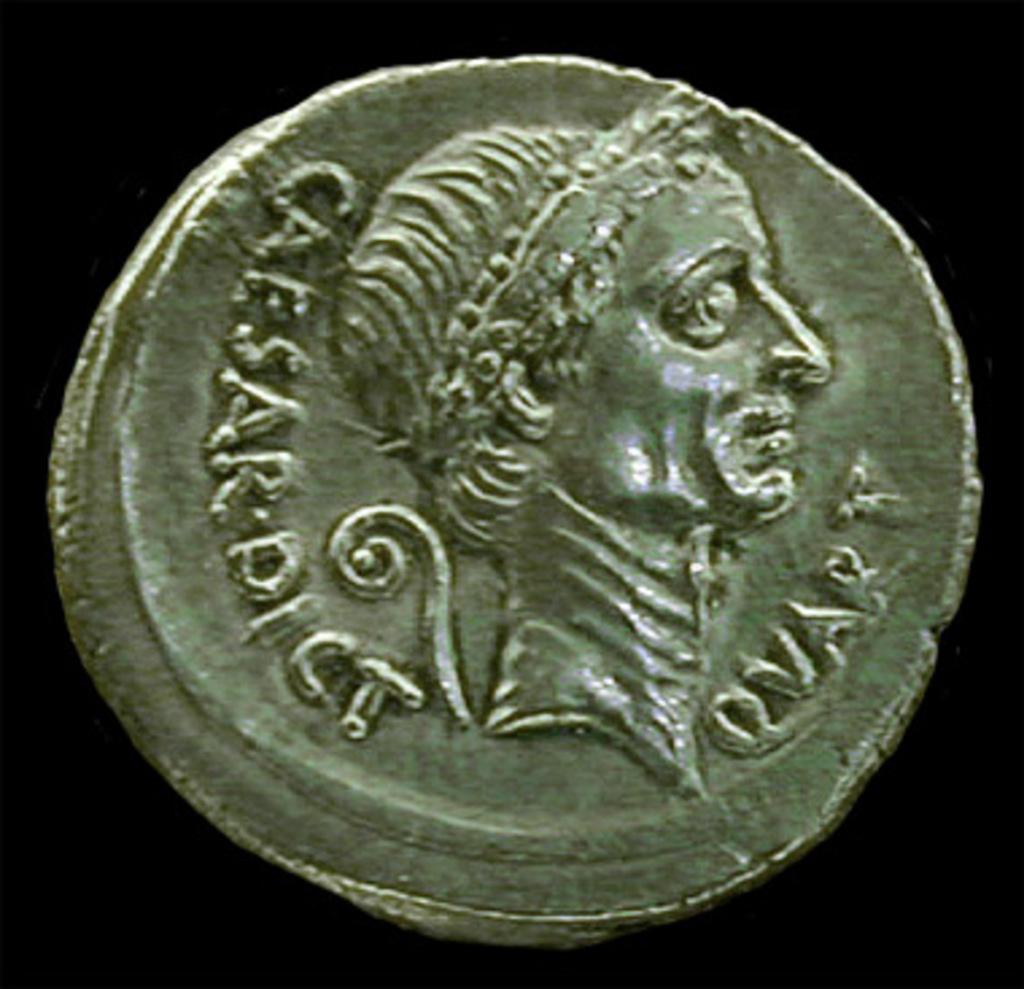Does the writing imply this is an image of caesar on this coin?
Provide a short and direct response. Yes. 